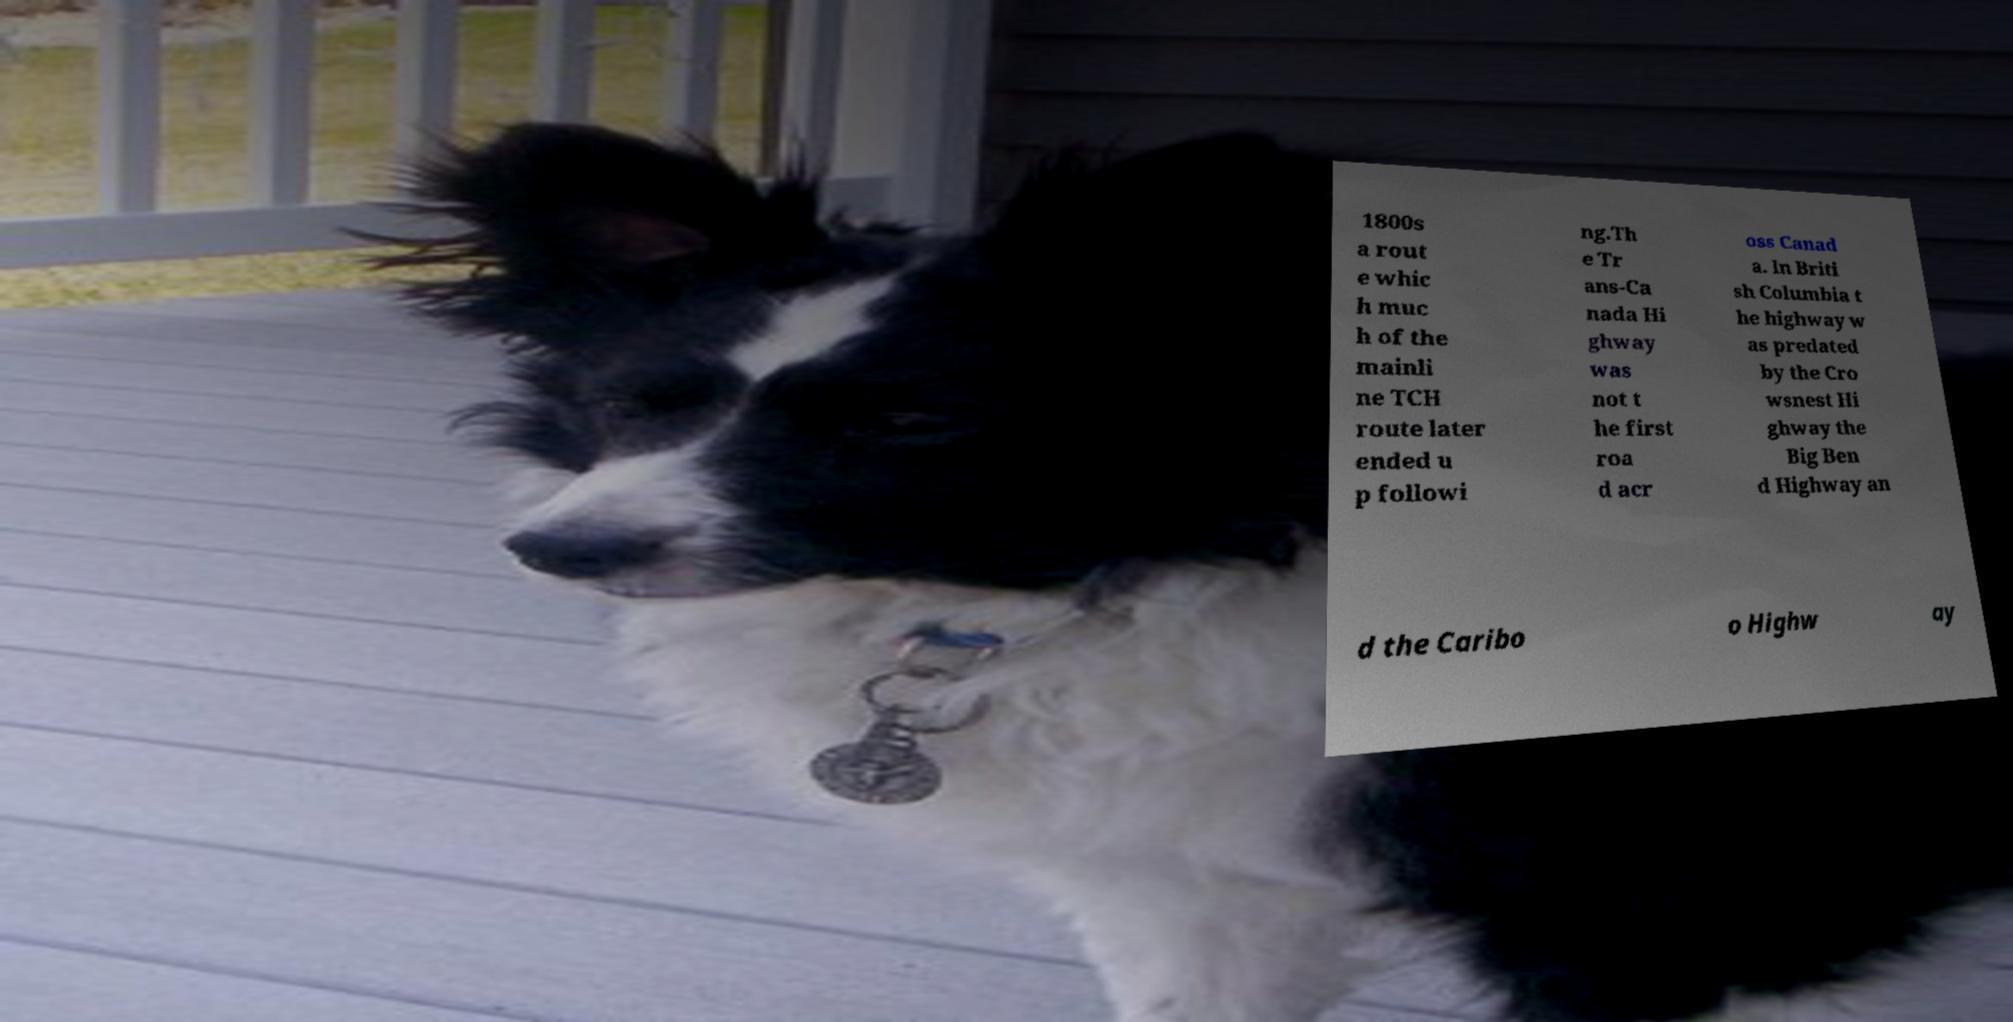There's text embedded in this image that I need extracted. Can you transcribe it verbatim? 1800s a rout e whic h muc h of the mainli ne TCH route later ended u p followi ng.Th e Tr ans-Ca nada Hi ghway was not t he first roa d acr oss Canad a. In Briti sh Columbia t he highway w as predated by the Cro wsnest Hi ghway the Big Ben d Highway an d the Caribo o Highw ay 